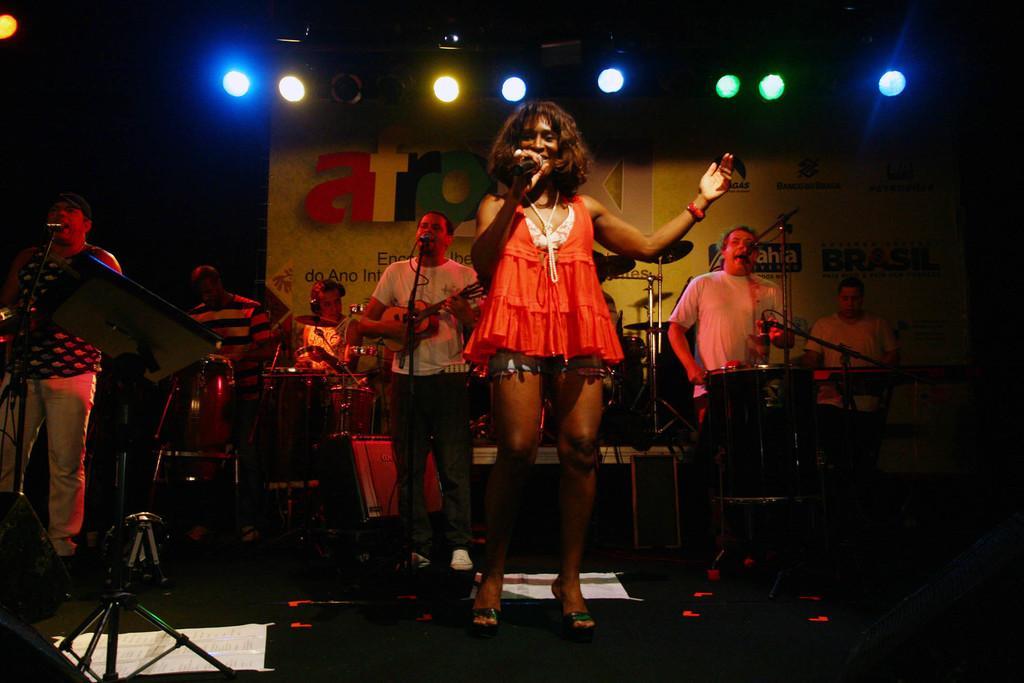Can you describe this image briefly? In this image we can see a group of people who are playing a musical band. They are singing on a microphone, playing a guitar and playing a snare drum with drum sticks. In the background we can see a lighting arrangement onto the roof. 